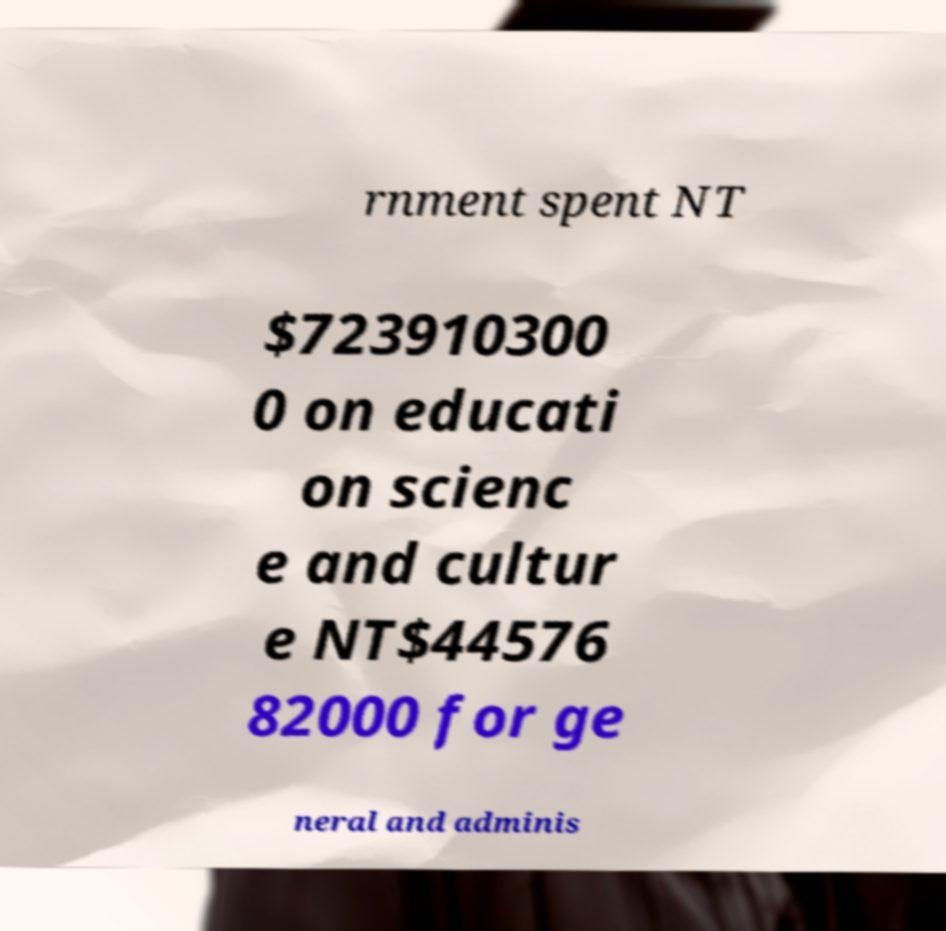Could you assist in decoding the text presented in this image and type it out clearly? rnment spent NT $723910300 0 on educati on scienc e and cultur e NT$44576 82000 for ge neral and adminis 